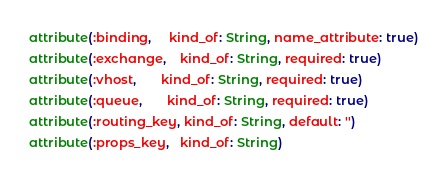<code> <loc_0><loc_0><loc_500><loc_500><_Ruby_>attribute(:binding,     kind_of: String, name_attribute: true)
attribute(:exchange,    kind_of: String, required: true)
attribute(:vhost,       kind_of: String, required: true)
attribute(:queue,       kind_of: String, required: true)
attribute(:routing_key, kind_of: String, default: '')
attribute(:props_key,   kind_of: String)
</code> 